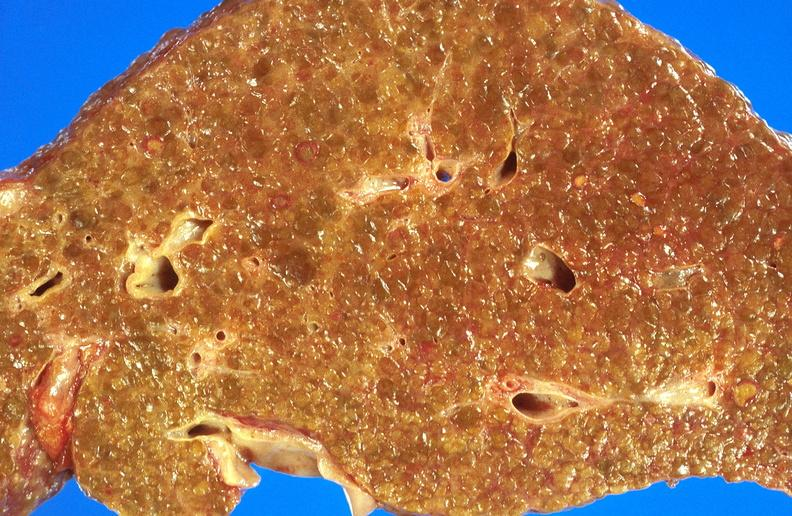what is present?
Answer the question using a single word or phrase. Hepatobiliary 